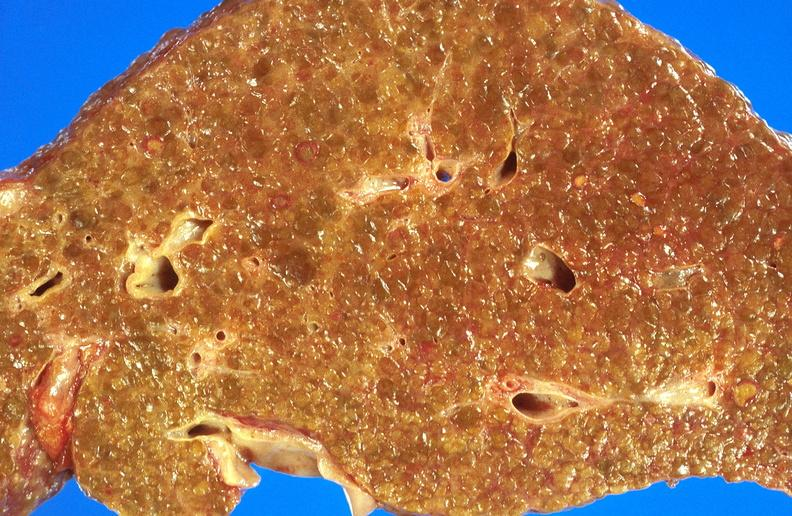what is present?
Answer the question using a single word or phrase. Hepatobiliary 